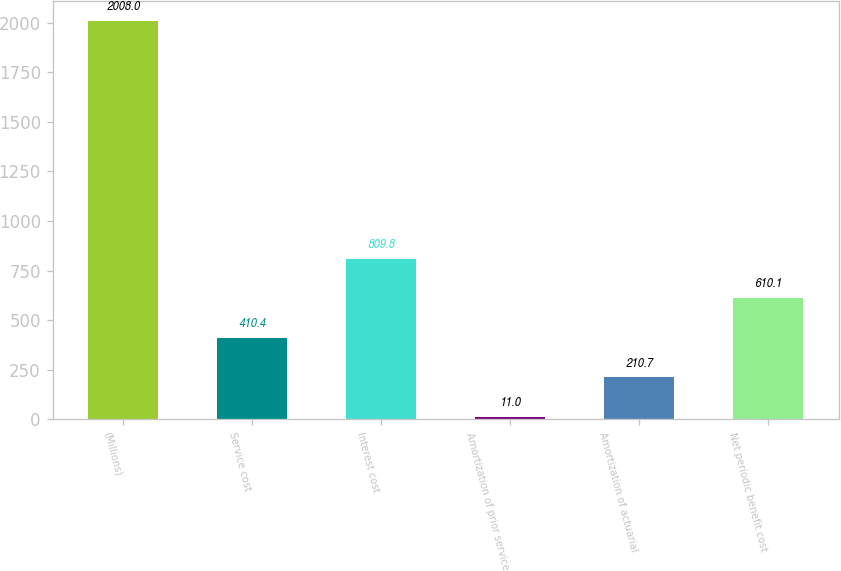<chart> <loc_0><loc_0><loc_500><loc_500><bar_chart><fcel>(Millions)<fcel>Service cost<fcel>Interest cost<fcel>Amortization of prior service<fcel>Amortization of actuarial<fcel>Net periodic benefit cost<nl><fcel>2008<fcel>410.4<fcel>809.8<fcel>11<fcel>210.7<fcel>610.1<nl></chart> 